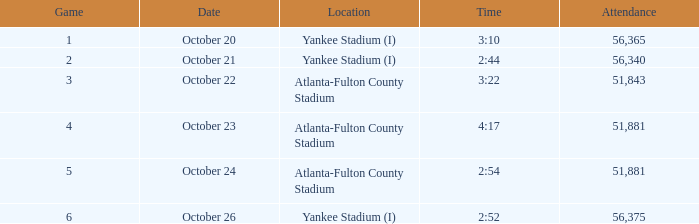What is the highest game number that had a time of 2:44? 2.0. 